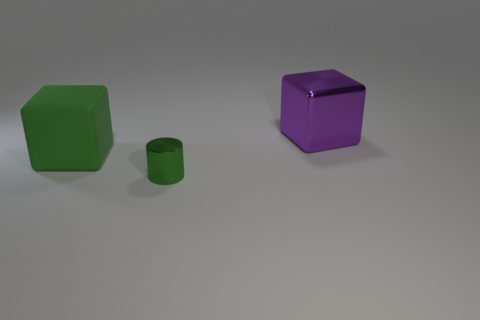Add 2 big rubber cubes. How many objects exist? 5 Subtract all blocks. How many objects are left? 1 Subtract all small purple cubes. Subtract all large green matte blocks. How many objects are left? 2 Add 1 big shiny things. How many big shiny things are left? 2 Add 1 big spheres. How many big spheres exist? 1 Subtract 0 blue balls. How many objects are left? 3 